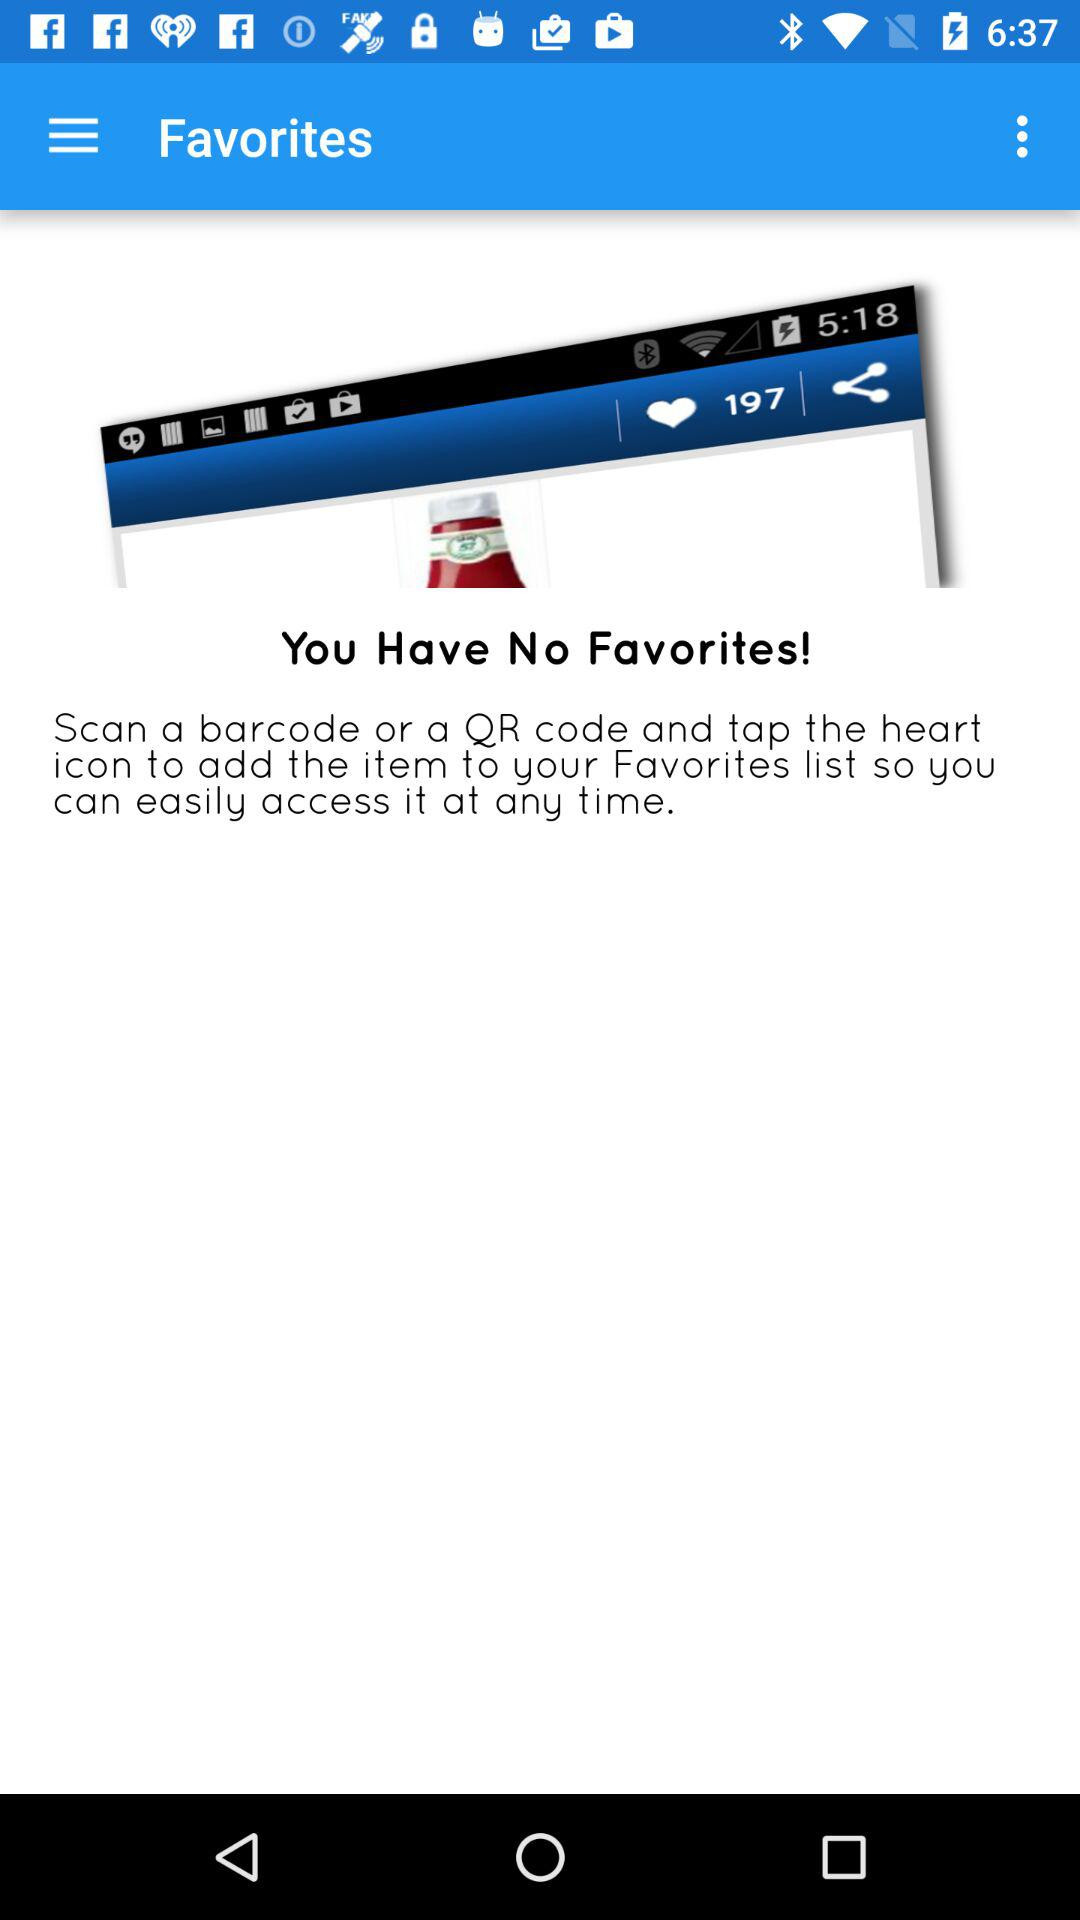How many items can be saved as favorites?
When the provided information is insufficient, respond with <no answer>. <no answer> 